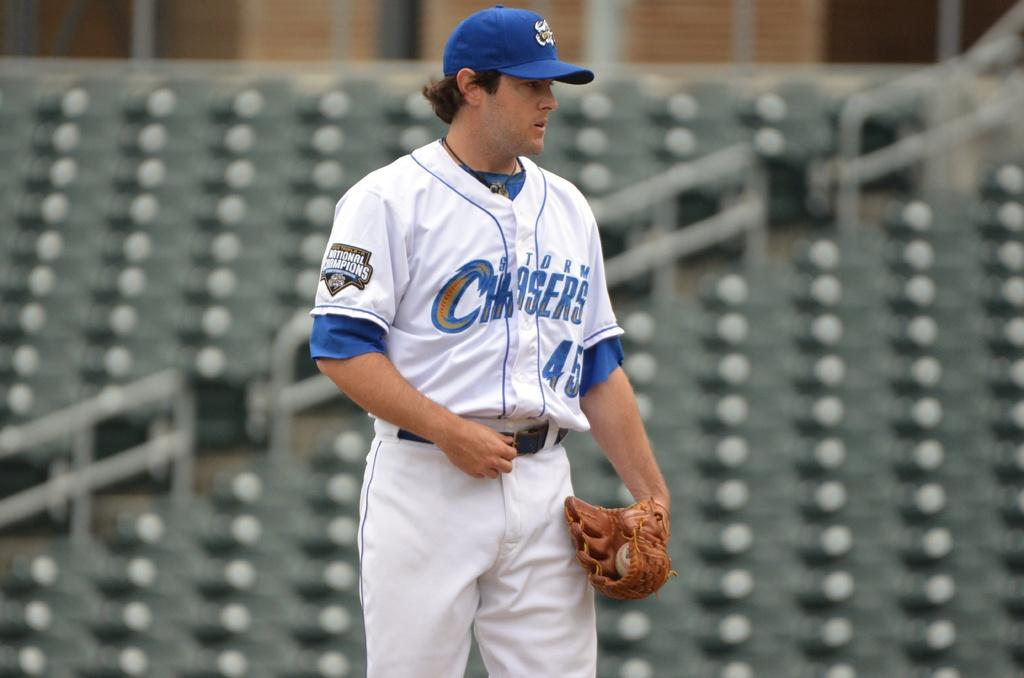What is the main subject of the image? There is a person in the image. What is the person wearing? The person is wearing a white dress. How does the person look in the image? The person appears stunning. Can you describe the background of the image? The background of the image is blurry. How many babies are present in the image? There are no babies present in the image; it features a person wearing a white dress. What type of camp can be seen in the background of the image? There is no camp present in the image; the background is blurry. 